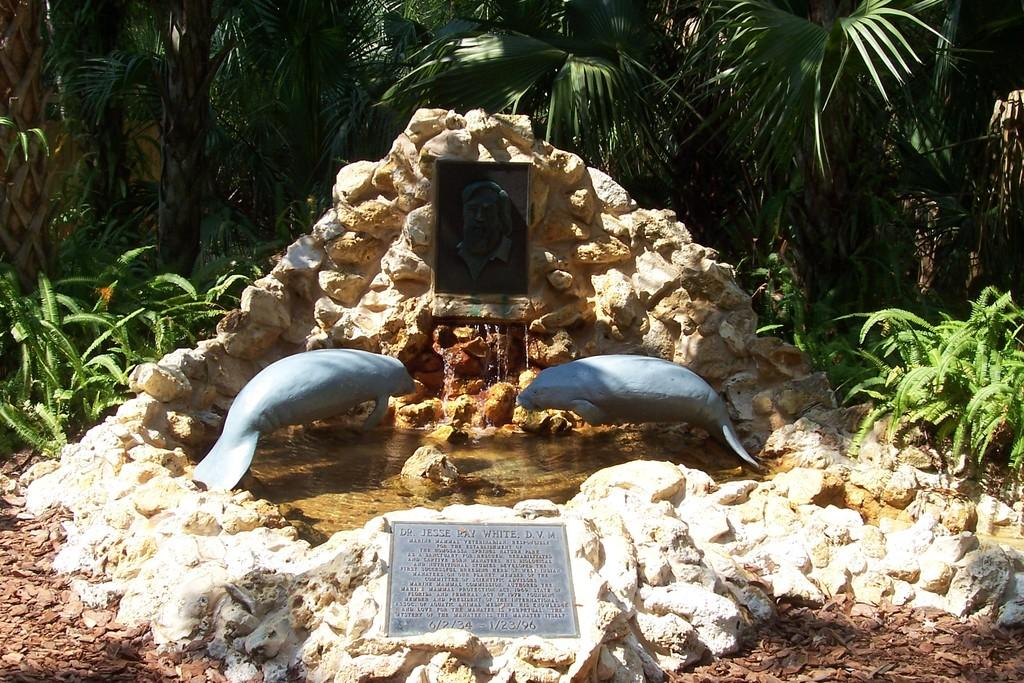What type of natural elements can be seen in the image? There are trees and plants in the image. What man-made objects are present in the image? There is a name board, a photo frame, sculptures, and a fountain in the image. Can you describe the purpose of the name board in the image? The name board in the image might indicate the name of a place or a person. What type of decorative element can be seen in the image? The photo frame and sculptures are decorative elements in the image. What feature in the image might provide a water source or visual appeal? The fountain in the image might provide a water source or visual appeal. What type of fiction is being read by the trees in the image? There are no trees reading fiction in the image, as trees do not have the ability to read. 